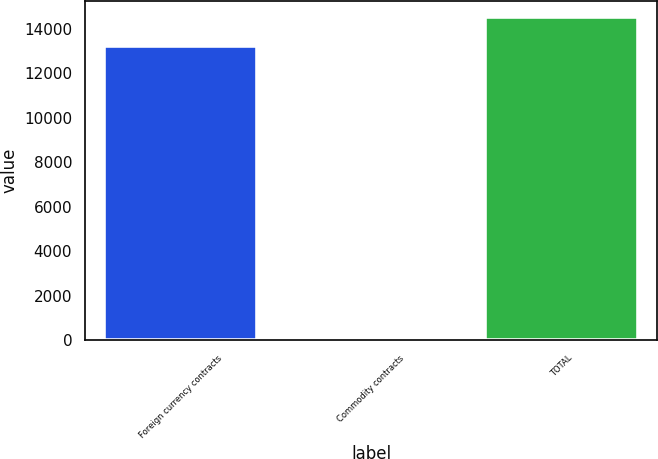Convert chart. <chart><loc_0><loc_0><loc_500><loc_500><bar_chart><fcel>Foreign currency contracts<fcel>Commodity contracts<fcel>TOTAL<nl><fcel>13210<fcel>125<fcel>14531<nl></chart> 